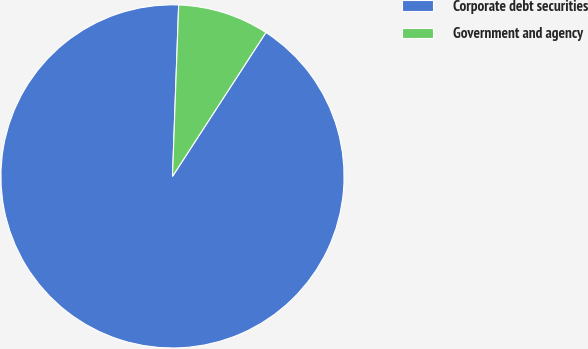Convert chart. <chart><loc_0><loc_0><loc_500><loc_500><pie_chart><fcel>Corporate debt securities<fcel>Government and agency<nl><fcel>91.41%<fcel>8.59%<nl></chart> 